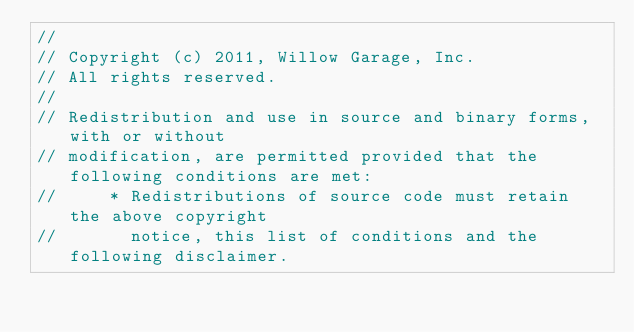<code> <loc_0><loc_0><loc_500><loc_500><_C++_>//
// Copyright (c) 2011, Willow Garage, Inc.
// All rights reserved.
//
// Redistribution and use in source and binary forms, with or without
// modification, are permitted provided that the following conditions are met:
//     * Redistributions of source code must retain the above copyright
//       notice, this list of conditions and the following disclaimer.</code> 